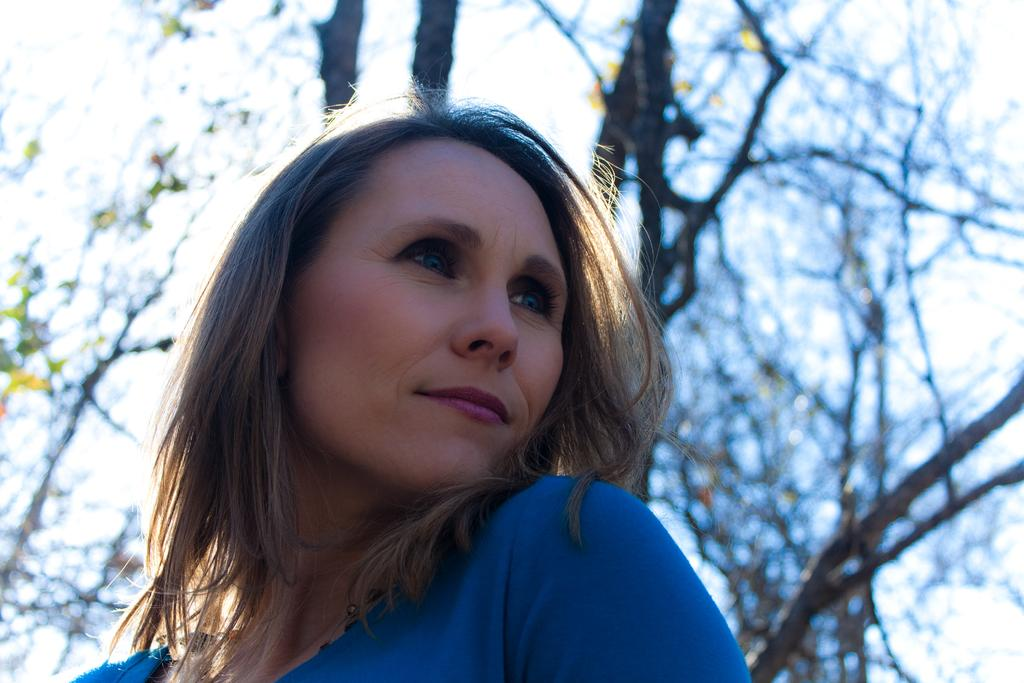Where was the image taken? The image was clicked outside. What is the main subject in the foreground of the image? There is a woman in the foreground of the image. What is the woman wearing? The woman is wearing a blue dress. What is the woman's posture in the image? The woman appears to be standing. What can be seen in the background of the image? There is sky and trees visible in the background of the image. What type of guitar is the woman playing in the image? There is no guitar present in the image; the woman is not playing any instrument. What kind of cream is being used to make the drink in the image? There is no drink or cream present in the image; the focus is on the woman and the background. 